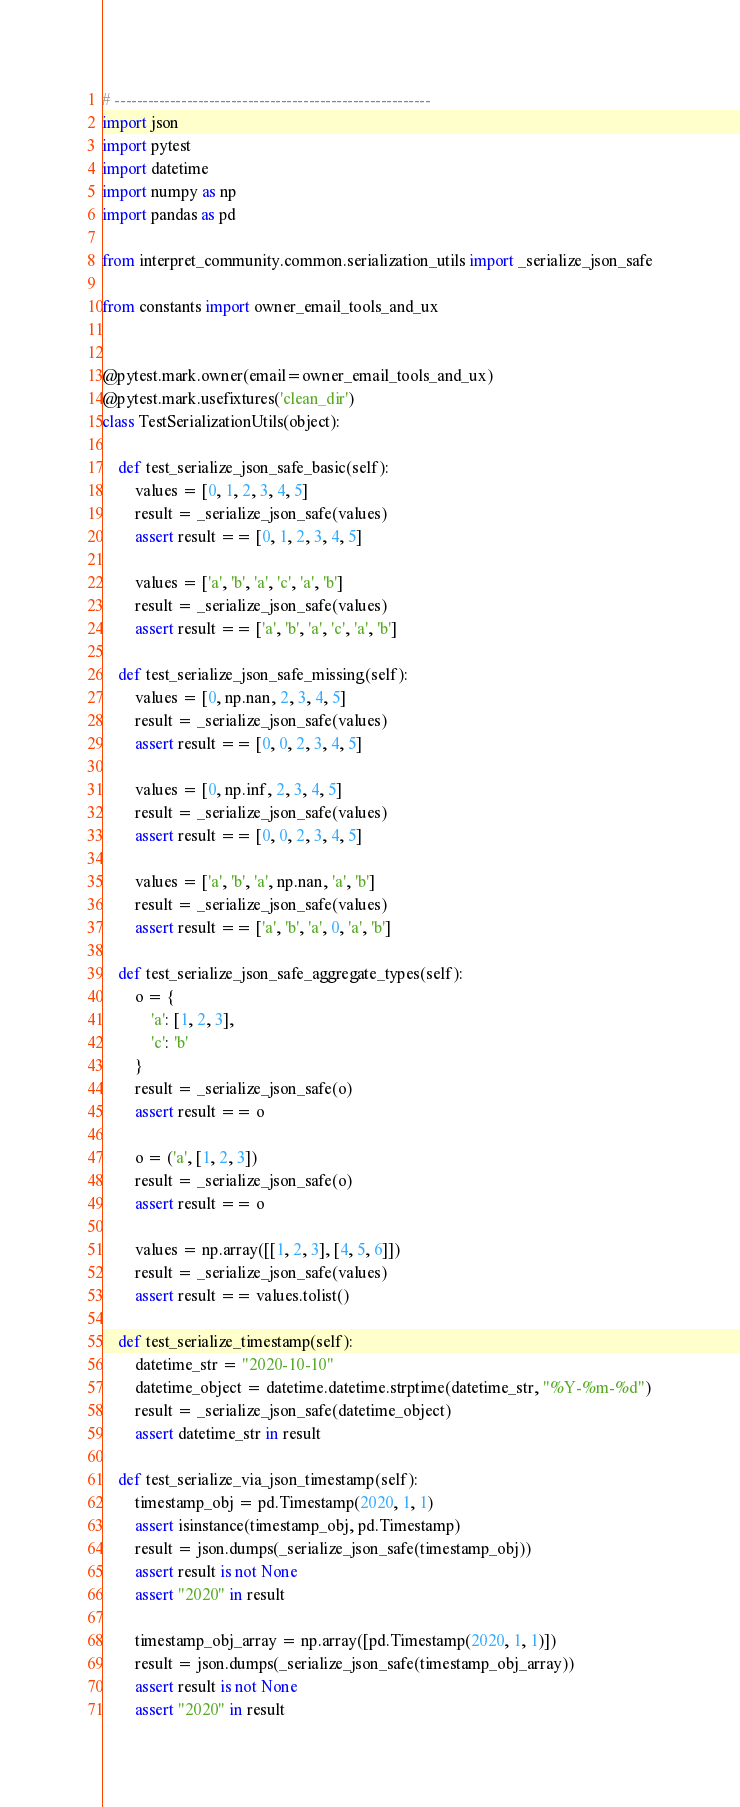Convert code to text. <code><loc_0><loc_0><loc_500><loc_500><_Python_># ---------------------------------------------------------
import json
import pytest
import datetime
import numpy as np
import pandas as pd

from interpret_community.common.serialization_utils import _serialize_json_safe

from constants import owner_email_tools_and_ux


@pytest.mark.owner(email=owner_email_tools_and_ux)
@pytest.mark.usefixtures('clean_dir')
class TestSerializationUtils(object):

    def test_serialize_json_safe_basic(self):
        values = [0, 1, 2, 3, 4, 5]
        result = _serialize_json_safe(values)
        assert result == [0, 1, 2, 3, 4, 5]

        values = ['a', 'b', 'a', 'c', 'a', 'b']
        result = _serialize_json_safe(values)
        assert result == ['a', 'b', 'a', 'c', 'a', 'b']

    def test_serialize_json_safe_missing(self):
        values = [0, np.nan, 2, 3, 4, 5]
        result = _serialize_json_safe(values)
        assert result == [0, 0, 2, 3, 4, 5]

        values = [0, np.inf, 2, 3, 4, 5]
        result = _serialize_json_safe(values)
        assert result == [0, 0, 2, 3, 4, 5]

        values = ['a', 'b', 'a', np.nan, 'a', 'b']
        result = _serialize_json_safe(values)
        assert result == ['a', 'b', 'a', 0, 'a', 'b']

    def test_serialize_json_safe_aggregate_types(self):
        o = {
            'a': [1, 2, 3],
            'c': 'b'
        }
        result = _serialize_json_safe(o)
        assert result == o

        o = ('a', [1, 2, 3])
        result = _serialize_json_safe(o)
        assert result == o

        values = np.array([[1, 2, 3], [4, 5, 6]])
        result = _serialize_json_safe(values)
        assert result == values.tolist()

    def test_serialize_timestamp(self):
        datetime_str = "2020-10-10"
        datetime_object = datetime.datetime.strptime(datetime_str, "%Y-%m-%d")
        result = _serialize_json_safe(datetime_object)
        assert datetime_str in result

    def test_serialize_via_json_timestamp(self):
        timestamp_obj = pd.Timestamp(2020, 1, 1)
        assert isinstance(timestamp_obj, pd.Timestamp)
        result = json.dumps(_serialize_json_safe(timestamp_obj))
        assert result is not None
        assert "2020" in result

        timestamp_obj_array = np.array([pd.Timestamp(2020, 1, 1)])
        result = json.dumps(_serialize_json_safe(timestamp_obj_array))
        assert result is not None
        assert "2020" in result
</code> 